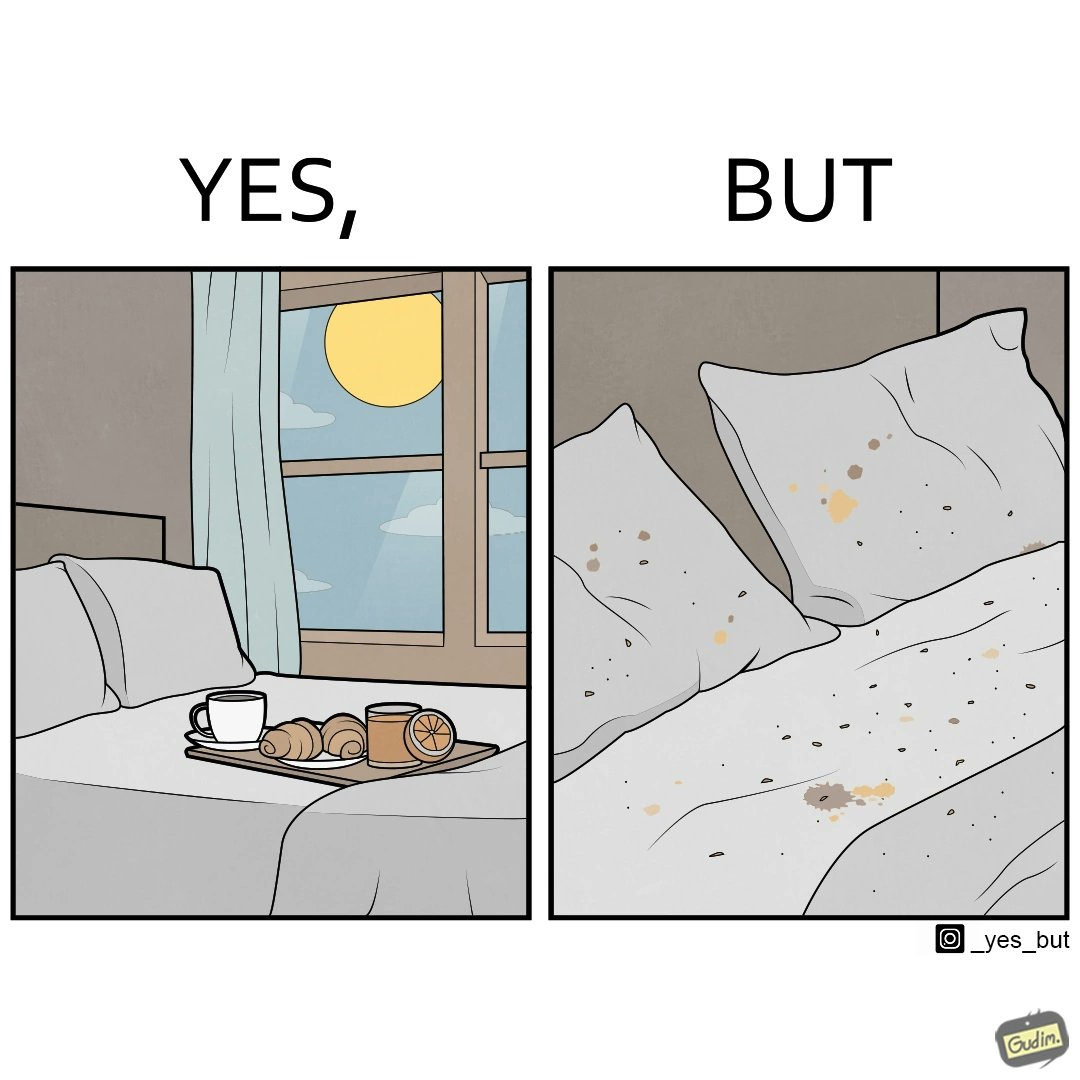Is there satirical content in this image? Yes, this image is satirical. 